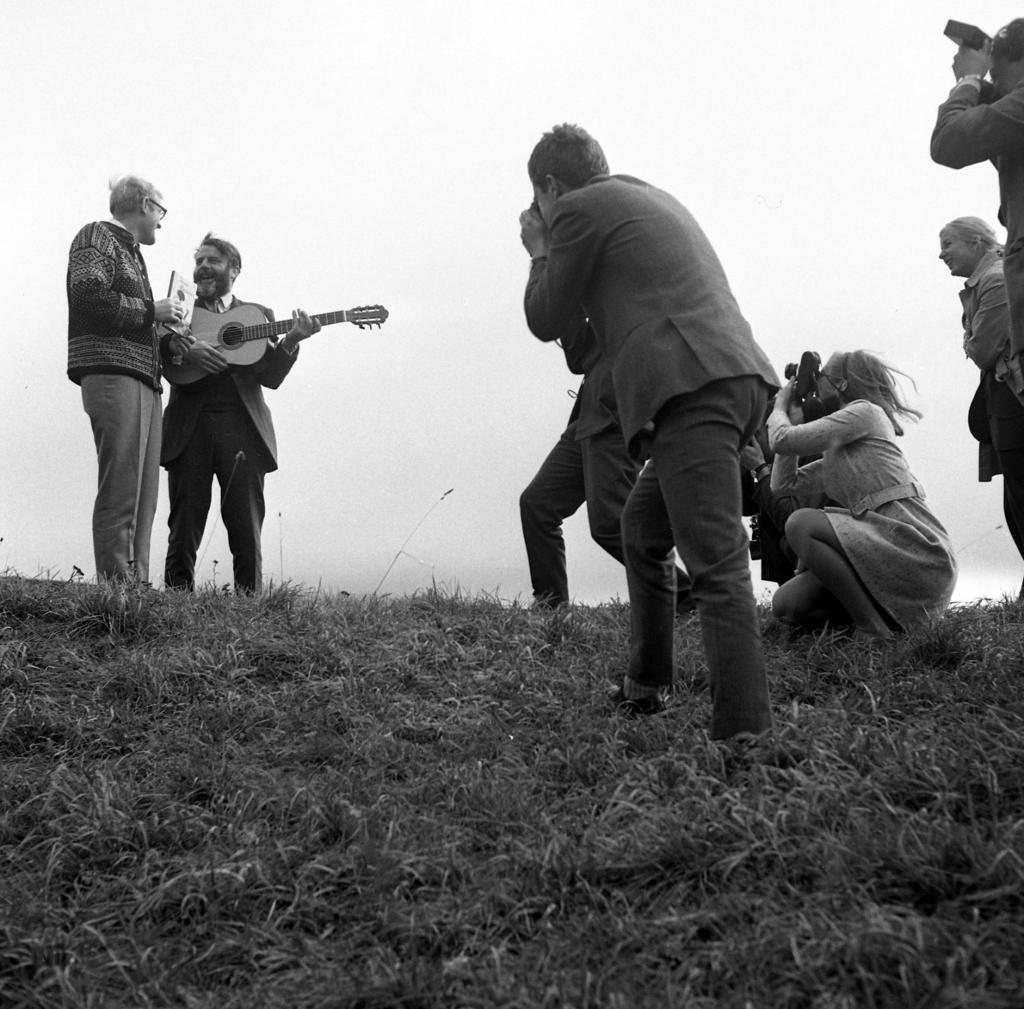Who or what can be seen in the image? There are people in the image. What are the people doing in the image? The people are standing and holding guitars in their hands. What is the ground made of in the image? The ground is filled with grass. What is the color scheme of the image? The image is in black and white color. Can you see a river flowing in the background of the image? There is no river visible in the image. Are there any socks visible on the people in the image? There is no mention of socks in the image, and no socks are visible on the people holding guitars. 